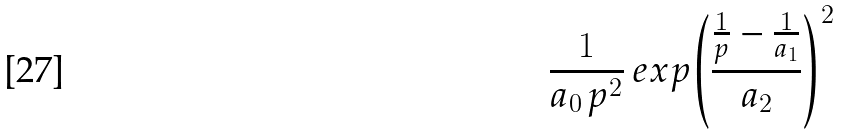<formula> <loc_0><loc_0><loc_500><loc_500>\frac { 1 } { a _ { 0 } \, p ^ { 2 } } \, e x p { \left ( { \frac { \frac { 1 } { p } - \frac { 1 } { a _ { 1 } } } { a _ { 2 } } } \right ) ^ { 2 } }</formula> 